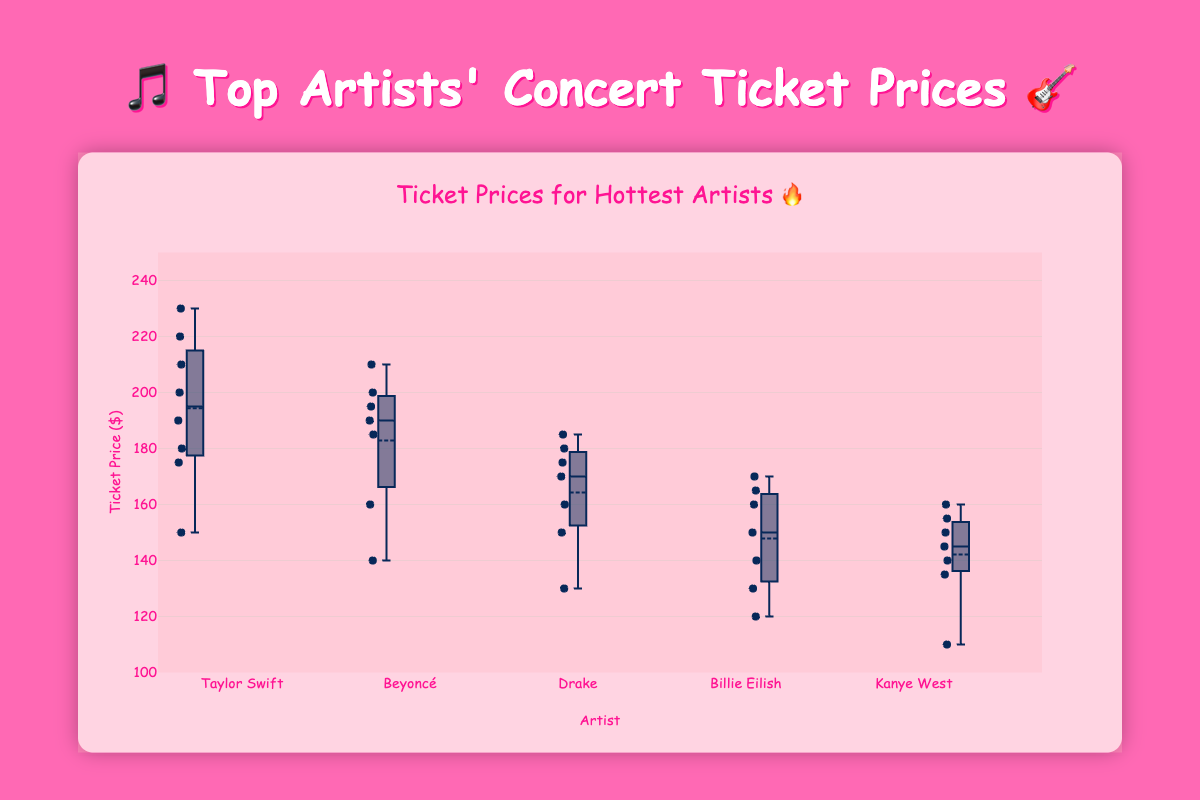What is the y-axis title? The title of the y-axis is clearly labeled in the figure to indicate what the y-axis represents. It's mentioned as "Ticket Price ($)" in the layout of the graph.
Answer: Ticket Price ($) What is the price range shown on the y-axis? The y-axis range is provided in the figure layout from 100 to 250 dollars.
Answer: 100 to 250 Which artist has the highest median ticket price? Observing the box plot, the artist whose box plot median line (usually indicated by the line inside the box) is the highest, thus indicating the highest median price, is Taylor Swift.
Answer: Taylor Swift What's the range of ticket prices for Beyoncé? The range of ticket prices can be found by looking at the minimum and maximum points (whiskers) of Beyoncé's box plot. Minimum is 140, and maximum is 210 dollars.
Answer: 140 to 210 dollars Which artist has the lowest maximum ticket price? By comparing the top whiskers of each box plot, Kanye West has the lowest maximum ticket price, indicated by the highest point of the Kanye West box plot being around 160 dollars.
Answer: Kanye West What’s the interquartile range (IQR) for Taylor Swift's ticket prices? The IQR is the difference between the third quartile (Q3) and the first quartile (Q1). For Taylor Swift, Q3 is around 217.5 and Q1 is around 177.5. So, IQR = 217.5 - 177.5 = 40 dollars.
Answer: 40 dollars Whose ticket prices show the most variability? Most variability is represented by the longest whisker and the widest box. Taylor Swift shows the most variability as its box plot spans the widest range.
Answer: Taylor Swift How does the median ticket price for Billie Eilish compare to Drake? By looking at the median lines in their respective box plots, Billie Eilish's median ticket price is slightly lower than Drake's.
Answer: Billie Eilish's is lower What is the median ticket price for Kanye West? The median is represented by the line inside the box. For Kanye West, this line is around 145 dollars.
Answer: 145 dollars Do any artists have ticket prices above 220 dollars? For an artist to have a price above 220 dollars, we look for any points or whiskers that extend beyond this amount. Only Taylor Swift has ticket prices above 220 dollars.
Answer: Taylor Swift 